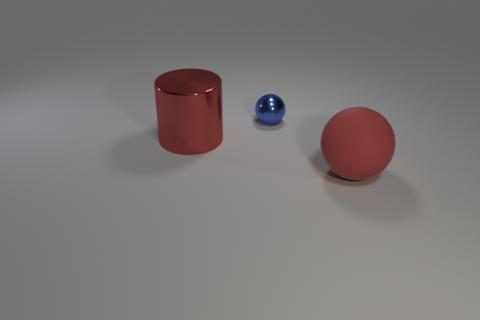Is there a big rubber thing of the same color as the cylinder?
Ensure brevity in your answer.  Yes. There is a big object that is the same color as the cylinder; what is it made of?
Make the answer very short. Rubber. There is a big cylinder that is made of the same material as the blue sphere; what is its color?
Make the answer very short. Red. There is a matte thing that is the same color as the big shiny cylinder; what shape is it?
Your answer should be compact. Sphere. Are there an equal number of large red spheres behind the red metallic object and spheres that are in front of the blue sphere?
Make the answer very short. No. What shape is the red object that is to the left of the large object that is in front of the big cylinder?
Give a very brief answer. Cylinder. What is the material of the other thing that is the same shape as the small shiny thing?
Keep it short and to the point. Rubber. There is a matte thing that is the same size as the red cylinder; what is its color?
Your answer should be compact. Red. Is the number of big things behind the blue sphere the same as the number of metallic things?
Ensure brevity in your answer.  No. What color is the big thing that is behind the thing that is in front of the red metal object?
Provide a succinct answer. Red. 